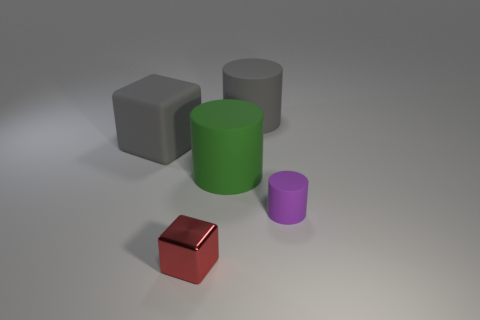Subtract all large matte cylinders. How many cylinders are left? 1 Add 2 gray cylinders. How many objects exist? 7 Subtract all purple cylinders. How many cylinders are left? 2 Subtract 3 cylinders. How many cylinders are left? 0 Subtract all cylinders. How many objects are left? 2 Subtract all gray cylinders. Subtract all cyan balls. How many cylinders are left? 2 Subtract all purple cylinders. How many red cubes are left? 1 Subtract all cyan matte cylinders. Subtract all large green things. How many objects are left? 4 Add 3 green rubber cylinders. How many green rubber cylinders are left? 4 Add 2 gray blocks. How many gray blocks exist? 3 